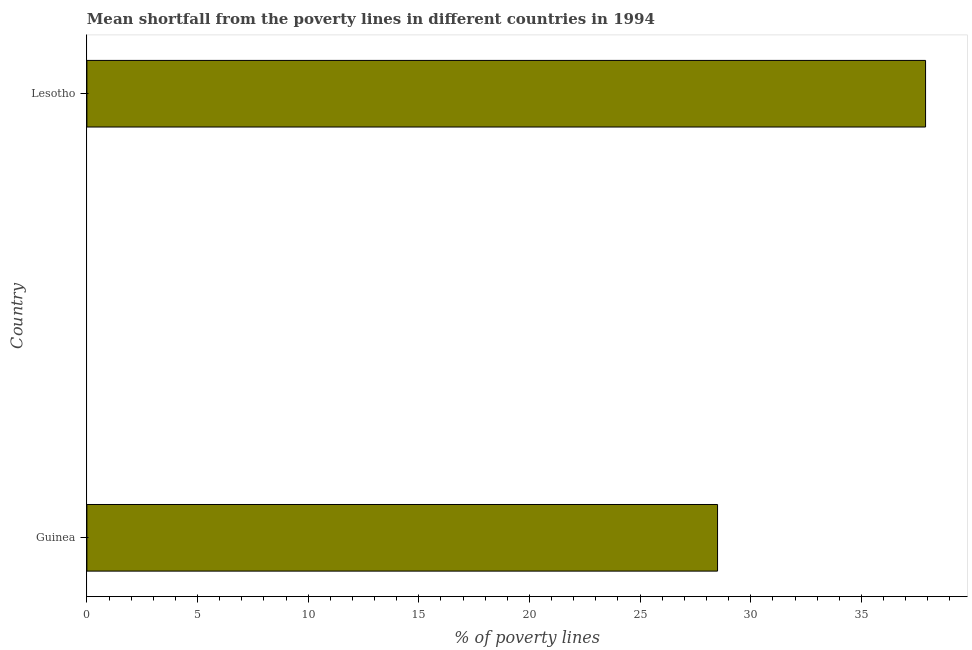Does the graph contain grids?
Keep it short and to the point. No. What is the title of the graph?
Make the answer very short. Mean shortfall from the poverty lines in different countries in 1994. What is the label or title of the X-axis?
Offer a very short reply. % of poverty lines. Across all countries, what is the maximum poverty gap at national poverty lines?
Your answer should be compact. 37.9. Across all countries, what is the minimum poverty gap at national poverty lines?
Keep it short and to the point. 28.5. In which country was the poverty gap at national poverty lines maximum?
Provide a succinct answer. Lesotho. In which country was the poverty gap at national poverty lines minimum?
Your answer should be compact. Guinea. What is the sum of the poverty gap at national poverty lines?
Your answer should be compact. 66.4. What is the difference between the poverty gap at national poverty lines in Guinea and Lesotho?
Offer a terse response. -9.4. What is the average poverty gap at national poverty lines per country?
Provide a succinct answer. 33.2. What is the median poverty gap at national poverty lines?
Provide a succinct answer. 33.2. In how many countries, is the poverty gap at national poverty lines greater than 24 %?
Give a very brief answer. 2. What is the ratio of the poverty gap at national poverty lines in Guinea to that in Lesotho?
Provide a short and direct response. 0.75. Is the poverty gap at national poverty lines in Guinea less than that in Lesotho?
Give a very brief answer. Yes. What is the difference between two consecutive major ticks on the X-axis?
Your response must be concise. 5. Are the values on the major ticks of X-axis written in scientific E-notation?
Provide a short and direct response. No. What is the % of poverty lines of Lesotho?
Your answer should be very brief. 37.9. What is the ratio of the % of poverty lines in Guinea to that in Lesotho?
Offer a terse response. 0.75. 